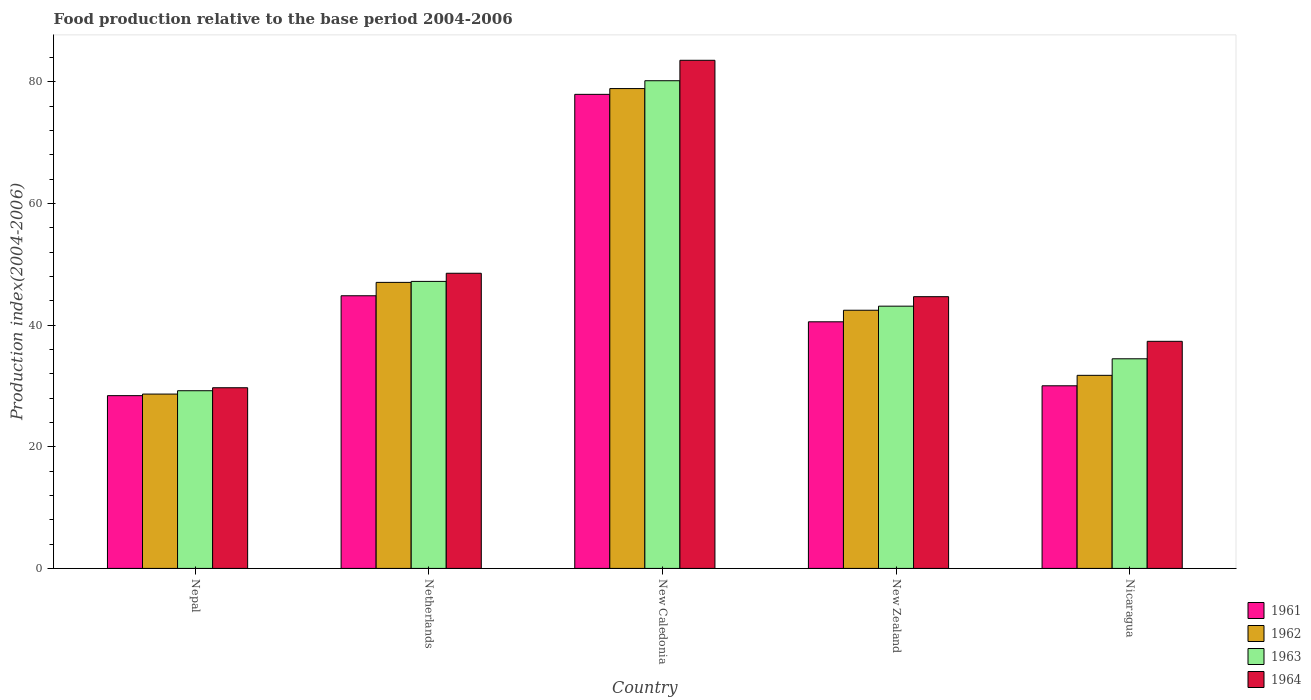How many bars are there on the 1st tick from the left?
Your response must be concise. 4. How many bars are there on the 1st tick from the right?
Offer a very short reply. 4. What is the label of the 3rd group of bars from the left?
Ensure brevity in your answer.  New Caledonia. What is the food production index in 1963 in Nepal?
Your response must be concise. 29.21. Across all countries, what is the maximum food production index in 1961?
Your response must be concise. 77.93. Across all countries, what is the minimum food production index in 1961?
Ensure brevity in your answer.  28.4. In which country was the food production index in 1964 maximum?
Ensure brevity in your answer.  New Caledonia. In which country was the food production index in 1964 minimum?
Make the answer very short. Nepal. What is the total food production index in 1961 in the graph?
Give a very brief answer. 221.71. What is the difference between the food production index in 1961 in New Caledonia and that in New Zealand?
Provide a succinct answer. 37.39. What is the difference between the food production index in 1961 in Nepal and the food production index in 1963 in Nicaragua?
Your response must be concise. -6.06. What is the average food production index in 1962 per country?
Your answer should be very brief. 45.75. What is the difference between the food production index of/in 1961 and food production index of/in 1963 in New Caledonia?
Your answer should be compact. -2.24. What is the ratio of the food production index in 1963 in New Caledonia to that in Nicaragua?
Provide a short and direct response. 2.33. Is the difference between the food production index in 1961 in Netherlands and New Zealand greater than the difference between the food production index in 1963 in Netherlands and New Zealand?
Your response must be concise. Yes. What is the difference between the highest and the second highest food production index in 1964?
Your response must be concise. -35.01. What is the difference between the highest and the lowest food production index in 1963?
Give a very brief answer. 50.96. In how many countries, is the food production index in 1963 greater than the average food production index in 1963 taken over all countries?
Provide a short and direct response. 2. Is the sum of the food production index in 1963 in New Caledonia and New Zealand greater than the maximum food production index in 1964 across all countries?
Provide a short and direct response. Yes. What does the 4th bar from the left in New Zealand represents?
Offer a very short reply. 1964. What does the 1st bar from the right in New Zealand represents?
Your answer should be very brief. 1964. Is it the case that in every country, the sum of the food production index in 1961 and food production index in 1964 is greater than the food production index in 1962?
Provide a short and direct response. Yes. How many bars are there?
Offer a terse response. 20. Are all the bars in the graph horizontal?
Give a very brief answer. No. What is the difference between two consecutive major ticks on the Y-axis?
Provide a succinct answer. 20. Does the graph contain any zero values?
Your answer should be very brief. No. How many legend labels are there?
Make the answer very short. 4. What is the title of the graph?
Give a very brief answer. Food production relative to the base period 2004-2006. Does "1989" appear as one of the legend labels in the graph?
Make the answer very short. No. What is the label or title of the Y-axis?
Your answer should be very brief. Production index(2004-2006). What is the Production index(2004-2006) in 1961 in Nepal?
Keep it short and to the point. 28.4. What is the Production index(2004-2006) of 1962 in Nepal?
Offer a very short reply. 28.66. What is the Production index(2004-2006) of 1963 in Nepal?
Give a very brief answer. 29.21. What is the Production index(2004-2006) of 1964 in Nepal?
Make the answer very short. 29.7. What is the Production index(2004-2006) of 1961 in Netherlands?
Make the answer very short. 44.82. What is the Production index(2004-2006) of 1962 in Netherlands?
Provide a succinct answer. 47.02. What is the Production index(2004-2006) of 1963 in Netherlands?
Your answer should be compact. 47.18. What is the Production index(2004-2006) of 1964 in Netherlands?
Keep it short and to the point. 48.52. What is the Production index(2004-2006) of 1961 in New Caledonia?
Give a very brief answer. 77.93. What is the Production index(2004-2006) of 1962 in New Caledonia?
Offer a terse response. 78.88. What is the Production index(2004-2006) in 1963 in New Caledonia?
Make the answer very short. 80.17. What is the Production index(2004-2006) of 1964 in New Caledonia?
Provide a succinct answer. 83.53. What is the Production index(2004-2006) in 1961 in New Zealand?
Ensure brevity in your answer.  40.54. What is the Production index(2004-2006) of 1962 in New Zealand?
Keep it short and to the point. 42.44. What is the Production index(2004-2006) of 1963 in New Zealand?
Your answer should be compact. 43.11. What is the Production index(2004-2006) of 1964 in New Zealand?
Your answer should be very brief. 44.67. What is the Production index(2004-2006) in 1961 in Nicaragua?
Give a very brief answer. 30.02. What is the Production index(2004-2006) of 1962 in Nicaragua?
Offer a terse response. 31.74. What is the Production index(2004-2006) in 1963 in Nicaragua?
Your response must be concise. 34.46. What is the Production index(2004-2006) in 1964 in Nicaragua?
Your answer should be compact. 37.33. Across all countries, what is the maximum Production index(2004-2006) of 1961?
Offer a terse response. 77.93. Across all countries, what is the maximum Production index(2004-2006) in 1962?
Offer a terse response. 78.88. Across all countries, what is the maximum Production index(2004-2006) in 1963?
Keep it short and to the point. 80.17. Across all countries, what is the maximum Production index(2004-2006) in 1964?
Offer a terse response. 83.53. Across all countries, what is the minimum Production index(2004-2006) of 1961?
Your response must be concise. 28.4. Across all countries, what is the minimum Production index(2004-2006) in 1962?
Provide a succinct answer. 28.66. Across all countries, what is the minimum Production index(2004-2006) of 1963?
Your answer should be compact. 29.21. Across all countries, what is the minimum Production index(2004-2006) of 1964?
Ensure brevity in your answer.  29.7. What is the total Production index(2004-2006) in 1961 in the graph?
Offer a very short reply. 221.71. What is the total Production index(2004-2006) of 1962 in the graph?
Offer a very short reply. 228.74. What is the total Production index(2004-2006) in 1963 in the graph?
Provide a short and direct response. 234.13. What is the total Production index(2004-2006) of 1964 in the graph?
Offer a terse response. 243.75. What is the difference between the Production index(2004-2006) in 1961 in Nepal and that in Netherlands?
Your answer should be very brief. -16.42. What is the difference between the Production index(2004-2006) of 1962 in Nepal and that in Netherlands?
Make the answer very short. -18.36. What is the difference between the Production index(2004-2006) in 1963 in Nepal and that in Netherlands?
Give a very brief answer. -17.97. What is the difference between the Production index(2004-2006) in 1964 in Nepal and that in Netherlands?
Your answer should be very brief. -18.82. What is the difference between the Production index(2004-2006) of 1961 in Nepal and that in New Caledonia?
Your answer should be very brief. -49.53. What is the difference between the Production index(2004-2006) of 1962 in Nepal and that in New Caledonia?
Offer a terse response. -50.22. What is the difference between the Production index(2004-2006) in 1963 in Nepal and that in New Caledonia?
Your response must be concise. -50.96. What is the difference between the Production index(2004-2006) in 1964 in Nepal and that in New Caledonia?
Your answer should be compact. -53.83. What is the difference between the Production index(2004-2006) in 1961 in Nepal and that in New Zealand?
Make the answer very short. -12.14. What is the difference between the Production index(2004-2006) in 1962 in Nepal and that in New Zealand?
Your response must be concise. -13.78. What is the difference between the Production index(2004-2006) in 1964 in Nepal and that in New Zealand?
Offer a very short reply. -14.97. What is the difference between the Production index(2004-2006) of 1961 in Nepal and that in Nicaragua?
Your answer should be very brief. -1.62. What is the difference between the Production index(2004-2006) in 1962 in Nepal and that in Nicaragua?
Your answer should be very brief. -3.08. What is the difference between the Production index(2004-2006) of 1963 in Nepal and that in Nicaragua?
Provide a succinct answer. -5.25. What is the difference between the Production index(2004-2006) in 1964 in Nepal and that in Nicaragua?
Make the answer very short. -7.63. What is the difference between the Production index(2004-2006) of 1961 in Netherlands and that in New Caledonia?
Keep it short and to the point. -33.11. What is the difference between the Production index(2004-2006) in 1962 in Netherlands and that in New Caledonia?
Make the answer very short. -31.86. What is the difference between the Production index(2004-2006) in 1963 in Netherlands and that in New Caledonia?
Ensure brevity in your answer.  -32.99. What is the difference between the Production index(2004-2006) of 1964 in Netherlands and that in New Caledonia?
Keep it short and to the point. -35.01. What is the difference between the Production index(2004-2006) of 1961 in Netherlands and that in New Zealand?
Your answer should be very brief. 4.28. What is the difference between the Production index(2004-2006) in 1962 in Netherlands and that in New Zealand?
Provide a short and direct response. 4.58. What is the difference between the Production index(2004-2006) in 1963 in Netherlands and that in New Zealand?
Your answer should be compact. 4.07. What is the difference between the Production index(2004-2006) of 1964 in Netherlands and that in New Zealand?
Give a very brief answer. 3.85. What is the difference between the Production index(2004-2006) of 1962 in Netherlands and that in Nicaragua?
Provide a short and direct response. 15.28. What is the difference between the Production index(2004-2006) in 1963 in Netherlands and that in Nicaragua?
Your response must be concise. 12.72. What is the difference between the Production index(2004-2006) of 1964 in Netherlands and that in Nicaragua?
Your answer should be very brief. 11.19. What is the difference between the Production index(2004-2006) of 1961 in New Caledonia and that in New Zealand?
Make the answer very short. 37.39. What is the difference between the Production index(2004-2006) of 1962 in New Caledonia and that in New Zealand?
Offer a terse response. 36.44. What is the difference between the Production index(2004-2006) in 1963 in New Caledonia and that in New Zealand?
Provide a succinct answer. 37.06. What is the difference between the Production index(2004-2006) of 1964 in New Caledonia and that in New Zealand?
Keep it short and to the point. 38.86. What is the difference between the Production index(2004-2006) in 1961 in New Caledonia and that in Nicaragua?
Make the answer very short. 47.91. What is the difference between the Production index(2004-2006) of 1962 in New Caledonia and that in Nicaragua?
Your response must be concise. 47.14. What is the difference between the Production index(2004-2006) in 1963 in New Caledonia and that in Nicaragua?
Give a very brief answer. 45.71. What is the difference between the Production index(2004-2006) of 1964 in New Caledonia and that in Nicaragua?
Provide a succinct answer. 46.2. What is the difference between the Production index(2004-2006) of 1961 in New Zealand and that in Nicaragua?
Give a very brief answer. 10.52. What is the difference between the Production index(2004-2006) of 1962 in New Zealand and that in Nicaragua?
Provide a succinct answer. 10.7. What is the difference between the Production index(2004-2006) in 1963 in New Zealand and that in Nicaragua?
Your response must be concise. 8.65. What is the difference between the Production index(2004-2006) in 1964 in New Zealand and that in Nicaragua?
Your response must be concise. 7.34. What is the difference between the Production index(2004-2006) in 1961 in Nepal and the Production index(2004-2006) in 1962 in Netherlands?
Give a very brief answer. -18.62. What is the difference between the Production index(2004-2006) of 1961 in Nepal and the Production index(2004-2006) of 1963 in Netherlands?
Your answer should be compact. -18.78. What is the difference between the Production index(2004-2006) in 1961 in Nepal and the Production index(2004-2006) in 1964 in Netherlands?
Provide a succinct answer. -20.12. What is the difference between the Production index(2004-2006) in 1962 in Nepal and the Production index(2004-2006) in 1963 in Netherlands?
Offer a terse response. -18.52. What is the difference between the Production index(2004-2006) of 1962 in Nepal and the Production index(2004-2006) of 1964 in Netherlands?
Give a very brief answer. -19.86. What is the difference between the Production index(2004-2006) of 1963 in Nepal and the Production index(2004-2006) of 1964 in Netherlands?
Provide a succinct answer. -19.31. What is the difference between the Production index(2004-2006) in 1961 in Nepal and the Production index(2004-2006) in 1962 in New Caledonia?
Make the answer very short. -50.48. What is the difference between the Production index(2004-2006) in 1961 in Nepal and the Production index(2004-2006) in 1963 in New Caledonia?
Provide a short and direct response. -51.77. What is the difference between the Production index(2004-2006) of 1961 in Nepal and the Production index(2004-2006) of 1964 in New Caledonia?
Provide a short and direct response. -55.13. What is the difference between the Production index(2004-2006) of 1962 in Nepal and the Production index(2004-2006) of 1963 in New Caledonia?
Provide a short and direct response. -51.51. What is the difference between the Production index(2004-2006) of 1962 in Nepal and the Production index(2004-2006) of 1964 in New Caledonia?
Make the answer very short. -54.87. What is the difference between the Production index(2004-2006) in 1963 in Nepal and the Production index(2004-2006) in 1964 in New Caledonia?
Your answer should be very brief. -54.32. What is the difference between the Production index(2004-2006) in 1961 in Nepal and the Production index(2004-2006) in 1962 in New Zealand?
Ensure brevity in your answer.  -14.04. What is the difference between the Production index(2004-2006) in 1961 in Nepal and the Production index(2004-2006) in 1963 in New Zealand?
Give a very brief answer. -14.71. What is the difference between the Production index(2004-2006) in 1961 in Nepal and the Production index(2004-2006) in 1964 in New Zealand?
Ensure brevity in your answer.  -16.27. What is the difference between the Production index(2004-2006) of 1962 in Nepal and the Production index(2004-2006) of 1963 in New Zealand?
Make the answer very short. -14.45. What is the difference between the Production index(2004-2006) of 1962 in Nepal and the Production index(2004-2006) of 1964 in New Zealand?
Offer a terse response. -16.01. What is the difference between the Production index(2004-2006) of 1963 in Nepal and the Production index(2004-2006) of 1964 in New Zealand?
Ensure brevity in your answer.  -15.46. What is the difference between the Production index(2004-2006) of 1961 in Nepal and the Production index(2004-2006) of 1962 in Nicaragua?
Provide a short and direct response. -3.34. What is the difference between the Production index(2004-2006) in 1961 in Nepal and the Production index(2004-2006) in 1963 in Nicaragua?
Make the answer very short. -6.06. What is the difference between the Production index(2004-2006) of 1961 in Nepal and the Production index(2004-2006) of 1964 in Nicaragua?
Offer a very short reply. -8.93. What is the difference between the Production index(2004-2006) in 1962 in Nepal and the Production index(2004-2006) in 1964 in Nicaragua?
Offer a terse response. -8.67. What is the difference between the Production index(2004-2006) in 1963 in Nepal and the Production index(2004-2006) in 1964 in Nicaragua?
Provide a succinct answer. -8.12. What is the difference between the Production index(2004-2006) of 1961 in Netherlands and the Production index(2004-2006) of 1962 in New Caledonia?
Keep it short and to the point. -34.06. What is the difference between the Production index(2004-2006) of 1961 in Netherlands and the Production index(2004-2006) of 1963 in New Caledonia?
Provide a short and direct response. -35.35. What is the difference between the Production index(2004-2006) in 1961 in Netherlands and the Production index(2004-2006) in 1964 in New Caledonia?
Ensure brevity in your answer.  -38.71. What is the difference between the Production index(2004-2006) in 1962 in Netherlands and the Production index(2004-2006) in 1963 in New Caledonia?
Keep it short and to the point. -33.15. What is the difference between the Production index(2004-2006) of 1962 in Netherlands and the Production index(2004-2006) of 1964 in New Caledonia?
Offer a terse response. -36.51. What is the difference between the Production index(2004-2006) in 1963 in Netherlands and the Production index(2004-2006) in 1964 in New Caledonia?
Provide a succinct answer. -36.35. What is the difference between the Production index(2004-2006) in 1961 in Netherlands and the Production index(2004-2006) in 1962 in New Zealand?
Your answer should be very brief. 2.38. What is the difference between the Production index(2004-2006) in 1961 in Netherlands and the Production index(2004-2006) in 1963 in New Zealand?
Offer a terse response. 1.71. What is the difference between the Production index(2004-2006) in 1961 in Netherlands and the Production index(2004-2006) in 1964 in New Zealand?
Provide a short and direct response. 0.15. What is the difference between the Production index(2004-2006) in 1962 in Netherlands and the Production index(2004-2006) in 1963 in New Zealand?
Your answer should be compact. 3.91. What is the difference between the Production index(2004-2006) of 1962 in Netherlands and the Production index(2004-2006) of 1964 in New Zealand?
Provide a short and direct response. 2.35. What is the difference between the Production index(2004-2006) in 1963 in Netherlands and the Production index(2004-2006) in 1964 in New Zealand?
Your response must be concise. 2.51. What is the difference between the Production index(2004-2006) of 1961 in Netherlands and the Production index(2004-2006) of 1962 in Nicaragua?
Make the answer very short. 13.08. What is the difference between the Production index(2004-2006) of 1961 in Netherlands and the Production index(2004-2006) of 1963 in Nicaragua?
Give a very brief answer. 10.36. What is the difference between the Production index(2004-2006) of 1961 in Netherlands and the Production index(2004-2006) of 1964 in Nicaragua?
Your answer should be very brief. 7.49. What is the difference between the Production index(2004-2006) in 1962 in Netherlands and the Production index(2004-2006) in 1963 in Nicaragua?
Make the answer very short. 12.56. What is the difference between the Production index(2004-2006) in 1962 in Netherlands and the Production index(2004-2006) in 1964 in Nicaragua?
Ensure brevity in your answer.  9.69. What is the difference between the Production index(2004-2006) of 1963 in Netherlands and the Production index(2004-2006) of 1964 in Nicaragua?
Keep it short and to the point. 9.85. What is the difference between the Production index(2004-2006) of 1961 in New Caledonia and the Production index(2004-2006) of 1962 in New Zealand?
Ensure brevity in your answer.  35.49. What is the difference between the Production index(2004-2006) in 1961 in New Caledonia and the Production index(2004-2006) in 1963 in New Zealand?
Provide a succinct answer. 34.82. What is the difference between the Production index(2004-2006) of 1961 in New Caledonia and the Production index(2004-2006) of 1964 in New Zealand?
Your answer should be compact. 33.26. What is the difference between the Production index(2004-2006) of 1962 in New Caledonia and the Production index(2004-2006) of 1963 in New Zealand?
Your answer should be very brief. 35.77. What is the difference between the Production index(2004-2006) of 1962 in New Caledonia and the Production index(2004-2006) of 1964 in New Zealand?
Offer a terse response. 34.21. What is the difference between the Production index(2004-2006) in 1963 in New Caledonia and the Production index(2004-2006) in 1964 in New Zealand?
Give a very brief answer. 35.5. What is the difference between the Production index(2004-2006) of 1961 in New Caledonia and the Production index(2004-2006) of 1962 in Nicaragua?
Provide a succinct answer. 46.19. What is the difference between the Production index(2004-2006) in 1961 in New Caledonia and the Production index(2004-2006) in 1963 in Nicaragua?
Your answer should be compact. 43.47. What is the difference between the Production index(2004-2006) in 1961 in New Caledonia and the Production index(2004-2006) in 1964 in Nicaragua?
Offer a terse response. 40.6. What is the difference between the Production index(2004-2006) of 1962 in New Caledonia and the Production index(2004-2006) of 1963 in Nicaragua?
Offer a terse response. 44.42. What is the difference between the Production index(2004-2006) in 1962 in New Caledonia and the Production index(2004-2006) in 1964 in Nicaragua?
Make the answer very short. 41.55. What is the difference between the Production index(2004-2006) in 1963 in New Caledonia and the Production index(2004-2006) in 1964 in Nicaragua?
Give a very brief answer. 42.84. What is the difference between the Production index(2004-2006) in 1961 in New Zealand and the Production index(2004-2006) in 1963 in Nicaragua?
Your answer should be compact. 6.08. What is the difference between the Production index(2004-2006) of 1961 in New Zealand and the Production index(2004-2006) of 1964 in Nicaragua?
Provide a short and direct response. 3.21. What is the difference between the Production index(2004-2006) in 1962 in New Zealand and the Production index(2004-2006) in 1963 in Nicaragua?
Offer a terse response. 7.98. What is the difference between the Production index(2004-2006) of 1962 in New Zealand and the Production index(2004-2006) of 1964 in Nicaragua?
Your response must be concise. 5.11. What is the difference between the Production index(2004-2006) in 1963 in New Zealand and the Production index(2004-2006) in 1964 in Nicaragua?
Your answer should be very brief. 5.78. What is the average Production index(2004-2006) in 1961 per country?
Keep it short and to the point. 44.34. What is the average Production index(2004-2006) of 1962 per country?
Make the answer very short. 45.75. What is the average Production index(2004-2006) of 1963 per country?
Keep it short and to the point. 46.83. What is the average Production index(2004-2006) of 1964 per country?
Keep it short and to the point. 48.75. What is the difference between the Production index(2004-2006) in 1961 and Production index(2004-2006) in 1962 in Nepal?
Provide a succinct answer. -0.26. What is the difference between the Production index(2004-2006) in 1961 and Production index(2004-2006) in 1963 in Nepal?
Keep it short and to the point. -0.81. What is the difference between the Production index(2004-2006) of 1961 and Production index(2004-2006) of 1964 in Nepal?
Make the answer very short. -1.3. What is the difference between the Production index(2004-2006) of 1962 and Production index(2004-2006) of 1963 in Nepal?
Your response must be concise. -0.55. What is the difference between the Production index(2004-2006) in 1962 and Production index(2004-2006) in 1964 in Nepal?
Your response must be concise. -1.04. What is the difference between the Production index(2004-2006) of 1963 and Production index(2004-2006) of 1964 in Nepal?
Your answer should be very brief. -0.49. What is the difference between the Production index(2004-2006) in 1961 and Production index(2004-2006) in 1963 in Netherlands?
Provide a succinct answer. -2.36. What is the difference between the Production index(2004-2006) in 1962 and Production index(2004-2006) in 1963 in Netherlands?
Provide a short and direct response. -0.16. What is the difference between the Production index(2004-2006) of 1963 and Production index(2004-2006) of 1964 in Netherlands?
Your response must be concise. -1.34. What is the difference between the Production index(2004-2006) of 1961 and Production index(2004-2006) of 1962 in New Caledonia?
Your answer should be compact. -0.95. What is the difference between the Production index(2004-2006) in 1961 and Production index(2004-2006) in 1963 in New Caledonia?
Provide a succinct answer. -2.24. What is the difference between the Production index(2004-2006) of 1962 and Production index(2004-2006) of 1963 in New Caledonia?
Ensure brevity in your answer.  -1.29. What is the difference between the Production index(2004-2006) of 1962 and Production index(2004-2006) of 1964 in New Caledonia?
Offer a very short reply. -4.65. What is the difference between the Production index(2004-2006) of 1963 and Production index(2004-2006) of 1964 in New Caledonia?
Provide a succinct answer. -3.36. What is the difference between the Production index(2004-2006) of 1961 and Production index(2004-2006) of 1962 in New Zealand?
Make the answer very short. -1.9. What is the difference between the Production index(2004-2006) in 1961 and Production index(2004-2006) in 1963 in New Zealand?
Ensure brevity in your answer.  -2.57. What is the difference between the Production index(2004-2006) of 1961 and Production index(2004-2006) of 1964 in New Zealand?
Your answer should be compact. -4.13. What is the difference between the Production index(2004-2006) in 1962 and Production index(2004-2006) in 1963 in New Zealand?
Your answer should be very brief. -0.67. What is the difference between the Production index(2004-2006) in 1962 and Production index(2004-2006) in 1964 in New Zealand?
Your response must be concise. -2.23. What is the difference between the Production index(2004-2006) in 1963 and Production index(2004-2006) in 1964 in New Zealand?
Ensure brevity in your answer.  -1.56. What is the difference between the Production index(2004-2006) in 1961 and Production index(2004-2006) in 1962 in Nicaragua?
Your answer should be compact. -1.72. What is the difference between the Production index(2004-2006) of 1961 and Production index(2004-2006) of 1963 in Nicaragua?
Provide a succinct answer. -4.44. What is the difference between the Production index(2004-2006) of 1961 and Production index(2004-2006) of 1964 in Nicaragua?
Your response must be concise. -7.31. What is the difference between the Production index(2004-2006) in 1962 and Production index(2004-2006) in 1963 in Nicaragua?
Ensure brevity in your answer.  -2.72. What is the difference between the Production index(2004-2006) of 1962 and Production index(2004-2006) of 1964 in Nicaragua?
Provide a succinct answer. -5.59. What is the difference between the Production index(2004-2006) in 1963 and Production index(2004-2006) in 1964 in Nicaragua?
Provide a succinct answer. -2.87. What is the ratio of the Production index(2004-2006) in 1961 in Nepal to that in Netherlands?
Offer a terse response. 0.63. What is the ratio of the Production index(2004-2006) in 1962 in Nepal to that in Netherlands?
Provide a short and direct response. 0.61. What is the ratio of the Production index(2004-2006) in 1963 in Nepal to that in Netherlands?
Provide a short and direct response. 0.62. What is the ratio of the Production index(2004-2006) of 1964 in Nepal to that in Netherlands?
Your answer should be compact. 0.61. What is the ratio of the Production index(2004-2006) of 1961 in Nepal to that in New Caledonia?
Make the answer very short. 0.36. What is the ratio of the Production index(2004-2006) of 1962 in Nepal to that in New Caledonia?
Provide a succinct answer. 0.36. What is the ratio of the Production index(2004-2006) of 1963 in Nepal to that in New Caledonia?
Offer a very short reply. 0.36. What is the ratio of the Production index(2004-2006) of 1964 in Nepal to that in New Caledonia?
Your answer should be compact. 0.36. What is the ratio of the Production index(2004-2006) in 1961 in Nepal to that in New Zealand?
Your response must be concise. 0.7. What is the ratio of the Production index(2004-2006) of 1962 in Nepal to that in New Zealand?
Keep it short and to the point. 0.68. What is the ratio of the Production index(2004-2006) of 1963 in Nepal to that in New Zealand?
Give a very brief answer. 0.68. What is the ratio of the Production index(2004-2006) in 1964 in Nepal to that in New Zealand?
Your answer should be compact. 0.66. What is the ratio of the Production index(2004-2006) in 1961 in Nepal to that in Nicaragua?
Give a very brief answer. 0.95. What is the ratio of the Production index(2004-2006) of 1962 in Nepal to that in Nicaragua?
Offer a terse response. 0.9. What is the ratio of the Production index(2004-2006) of 1963 in Nepal to that in Nicaragua?
Your answer should be compact. 0.85. What is the ratio of the Production index(2004-2006) in 1964 in Nepal to that in Nicaragua?
Your answer should be very brief. 0.8. What is the ratio of the Production index(2004-2006) of 1961 in Netherlands to that in New Caledonia?
Your answer should be very brief. 0.58. What is the ratio of the Production index(2004-2006) in 1962 in Netherlands to that in New Caledonia?
Your response must be concise. 0.6. What is the ratio of the Production index(2004-2006) of 1963 in Netherlands to that in New Caledonia?
Your response must be concise. 0.59. What is the ratio of the Production index(2004-2006) in 1964 in Netherlands to that in New Caledonia?
Ensure brevity in your answer.  0.58. What is the ratio of the Production index(2004-2006) in 1961 in Netherlands to that in New Zealand?
Offer a very short reply. 1.11. What is the ratio of the Production index(2004-2006) of 1962 in Netherlands to that in New Zealand?
Provide a succinct answer. 1.11. What is the ratio of the Production index(2004-2006) in 1963 in Netherlands to that in New Zealand?
Provide a succinct answer. 1.09. What is the ratio of the Production index(2004-2006) in 1964 in Netherlands to that in New Zealand?
Make the answer very short. 1.09. What is the ratio of the Production index(2004-2006) of 1961 in Netherlands to that in Nicaragua?
Your response must be concise. 1.49. What is the ratio of the Production index(2004-2006) of 1962 in Netherlands to that in Nicaragua?
Your response must be concise. 1.48. What is the ratio of the Production index(2004-2006) of 1963 in Netherlands to that in Nicaragua?
Offer a terse response. 1.37. What is the ratio of the Production index(2004-2006) of 1964 in Netherlands to that in Nicaragua?
Provide a short and direct response. 1.3. What is the ratio of the Production index(2004-2006) of 1961 in New Caledonia to that in New Zealand?
Make the answer very short. 1.92. What is the ratio of the Production index(2004-2006) in 1962 in New Caledonia to that in New Zealand?
Offer a terse response. 1.86. What is the ratio of the Production index(2004-2006) of 1963 in New Caledonia to that in New Zealand?
Keep it short and to the point. 1.86. What is the ratio of the Production index(2004-2006) in 1964 in New Caledonia to that in New Zealand?
Make the answer very short. 1.87. What is the ratio of the Production index(2004-2006) in 1961 in New Caledonia to that in Nicaragua?
Ensure brevity in your answer.  2.6. What is the ratio of the Production index(2004-2006) of 1962 in New Caledonia to that in Nicaragua?
Your answer should be compact. 2.49. What is the ratio of the Production index(2004-2006) of 1963 in New Caledonia to that in Nicaragua?
Give a very brief answer. 2.33. What is the ratio of the Production index(2004-2006) of 1964 in New Caledonia to that in Nicaragua?
Your answer should be compact. 2.24. What is the ratio of the Production index(2004-2006) of 1961 in New Zealand to that in Nicaragua?
Your answer should be very brief. 1.35. What is the ratio of the Production index(2004-2006) of 1962 in New Zealand to that in Nicaragua?
Provide a succinct answer. 1.34. What is the ratio of the Production index(2004-2006) in 1963 in New Zealand to that in Nicaragua?
Keep it short and to the point. 1.25. What is the ratio of the Production index(2004-2006) of 1964 in New Zealand to that in Nicaragua?
Give a very brief answer. 1.2. What is the difference between the highest and the second highest Production index(2004-2006) in 1961?
Provide a succinct answer. 33.11. What is the difference between the highest and the second highest Production index(2004-2006) in 1962?
Make the answer very short. 31.86. What is the difference between the highest and the second highest Production index(2004-2006) in 1963?
Your answer should be compact. 32.99. What is the difference between the highest and the second highest Production index(2004-2006) of 1964?
Your response must be concise. 35.01. What is the difference between the highest and the lowest Production index(2004-2006) of 1961?
Give a very brief answer. 49.53. What is the difference between the highest and the lowest Production index(2004-2006) in 1962?
Offer a terse response. 50.22. What is the difference between the highest and the lowest Production index(2004-2006) of 1963?
Your response must be concise. 50.96. What is the difference between the highest and the lowest Production index(2004-2006) in 1964?
Your answer should be very brief. 53.83. 